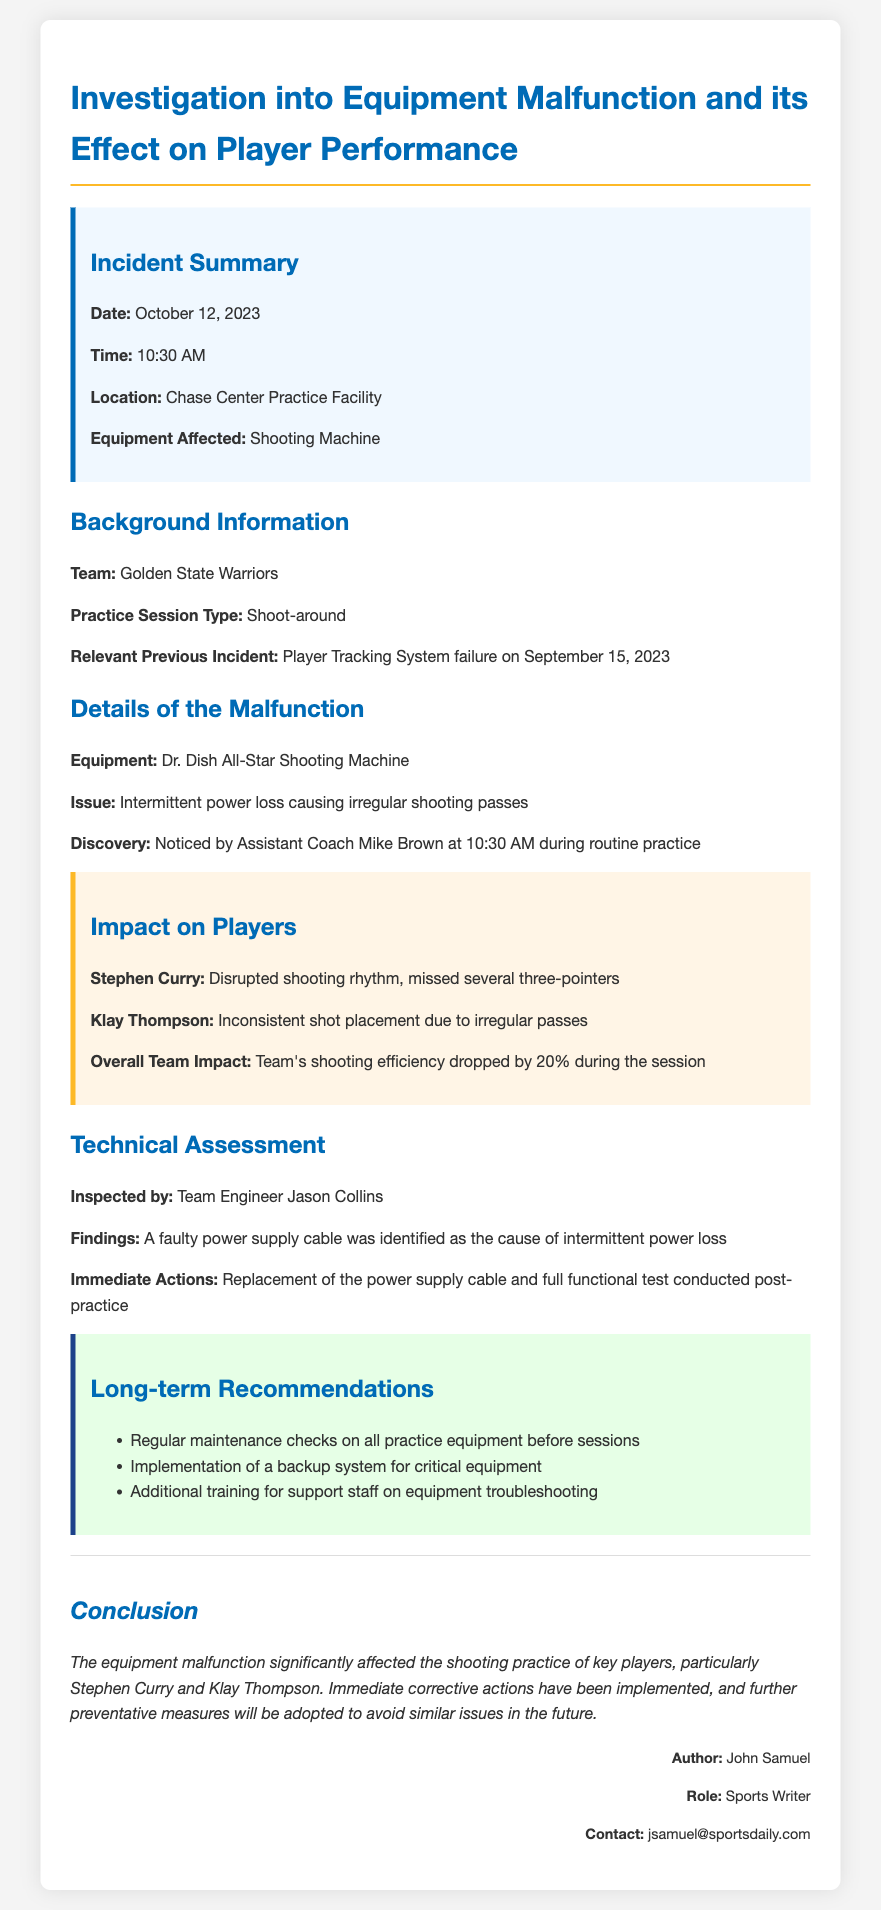What was the date of the incident? The incident date is clearly stated in the document as October 12, 2023.
Answer: October 12, 2023 What was the main issue discovered during the practice? The document specifies that the issue was intermittent power loss causing irregular shooting passes.
Answer: Intermittent power loss Who identified the equipment malfunction? The report mentions that Assistant Coach Mike Brown noticed the malfunction during practice.
Answer: Assistant Coach Mike Brown How much did the team's shooting efficiency drop during the session? The document indicates that the shooting efficiency dropped by 20% during the practice session.
Answer: 20% What was the affected equipment? The report details that the Dr. Dish All-Star Shooting Machine was the equipment affected by the malfunction.
Answer: Dr. Dish All-Star Shooting Machine Which players were notably impacted by the malfunction? The report lists Stephen Curry and Klay Thompson as the key players affected during the shooting practice.
Answer: Stephen Curry and Klay Thompson What immediate action was taken to address the malfunction? The document states that the power supply cable was replaced as an immediate corrective action.
Answer: Replacement of the power supply cable Who conducted the technical assessment? The document specifies that the inspection was carried out by Team Engineer Jason Collins.
Answer: Team Engineer Jason Collins What type of practice session was affected? The report indicates that the practice session type was a shoot-around.
Answer: Shoot-around 